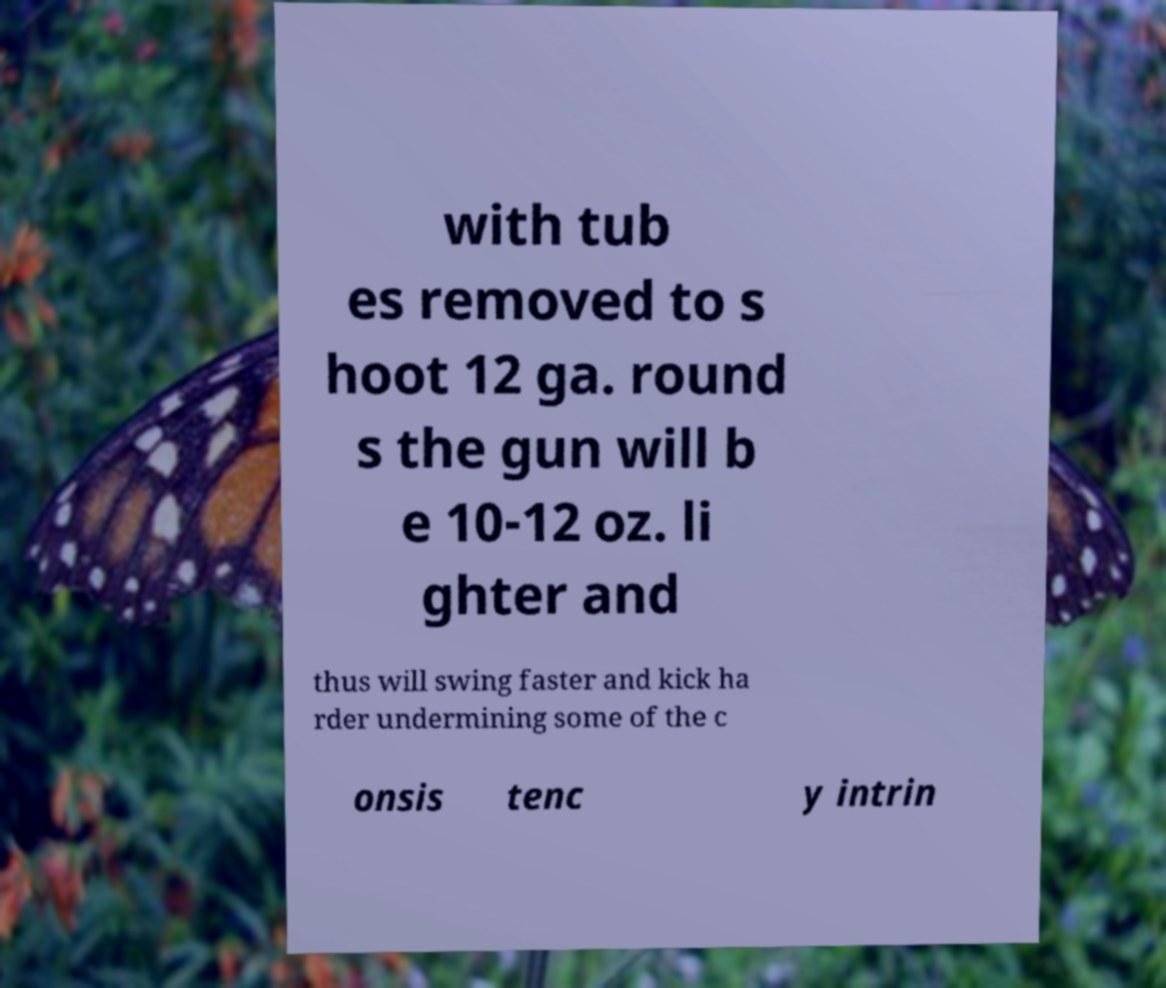For documentation purposes, I need the text within this image transcribed. Could you provide that? with tub es removed to s hoot 12 ga. round s the gun will b e 10-12 oz. li ghter and thus will swing faster and kick ha rder undermining some of the c onsis tenc y intrin 